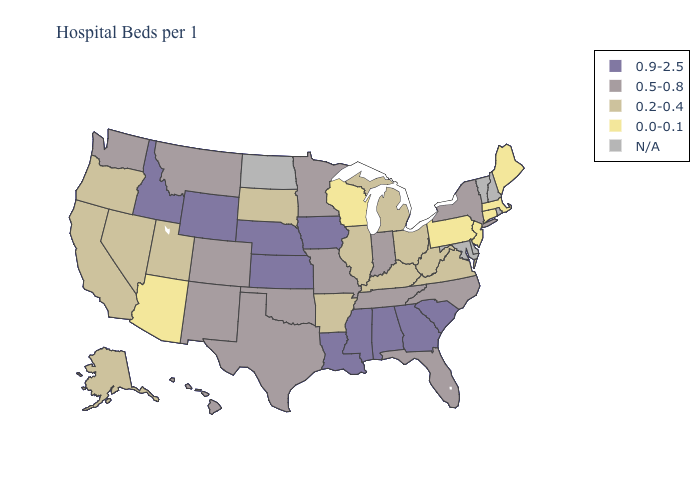What is the lowest value in the Northeast?
Keep it brief. 0.0-0.1. What is the value of Nevada?
Keep it brief. 0.2-0.4. Does Massachusetts have the lowest value in the USA?
Answer briefly. Yes. Name the states that have a value in the range 0.9-2.5?
Quick response, please. Alabama, Georgia, Idaho, Iowa, Kansas, Louisiana, Mississippi, Nebraska, South Carolina, Wyoming. Among the states that border Pennsylvania , does Ohio have the lowest value?
Be succinct. No. Which states have the highest value in the USA?
Answer briefly. Alabama, Georgia, Idaho, Iowa, Kansas, Louisiana, Mississippi, Nebraska, South Carolina, Wyoming. Name the states that have a value in the range 0.9-2.5?
Keep it brief. Alabama, Georgia, Idaho, Iowa, Kansas, Louisiana, Mississippi, Nebraska, South Carolina, Wyoming. Which states hav the highest value in the MidWest?
Be succinct. Iowa, Kansas, Nebraska. What is the value of Missouri?
Concise answer only. 0.5-0.8. Name the states that have a value in the range 0.2-0.4?
Give a very brief answer. Alaska, Arkansas, California, Illinois, Kentucky, Michigan, Nevada, Ohio, Oregon, South Dakota, Utah, Virginia, West Virginia. What is the value of Idaho?
Keep it brief. 0.9-2.5. Which states have the lowest value in the USA?
Short answer required. Arizona, Connecticut, Maine, Massachusetts, New Jersey, Pennsylvania, Wisconsin. 